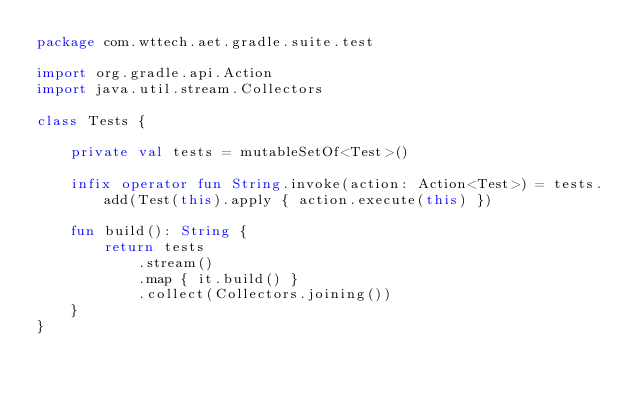Convert code to text. <code><loc_0><loc_0><loc_500><loc_500><_Kotlin_>package com.wttech.aet.gradle.suite.test

import org.gradle.api.Action
import java.util.stream.Collectors

class Tests {

    private val tests = mutableSetOf<Test>()

    infix operator fun String.invoke(action: Action<Test>) = tests.add(Test(this).apply { action.execute(this) })

    fun build(): String {
        return tests
            .stream()
            .map { it.build() }
            .collect(Collectors.joining())
    }
}</code> 